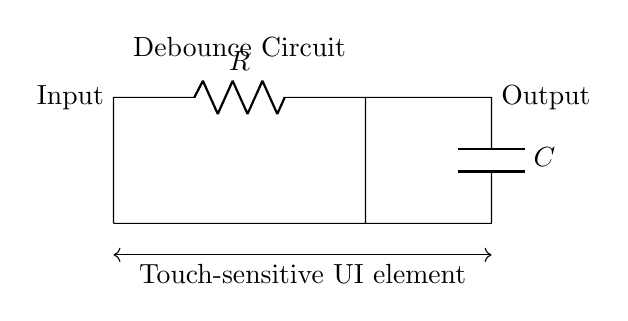What components are present in this circuit? The circuit includes a resistor labeled R and a capacitor labeled C. These are the primary components responsible for the functionality of the debounce circuit.
Answer: Resistor and Capacitor What does the input node represent? The input node is connected to the touch-sensitive UI element, which is the source of the signal that the circuit will debounce. It converts mechanical touch into an electrical signal.
Answer: Touch-sensitive UI element What is the purpose of the capacitor in this circuit? The capacitor stores electrical charge and works with the resistor to filter out rapid fluctuations in the input signal, smoothing the transition and effectively debouncing the signal.
Answer: Filter noise What kind of circuit is this? This is a resistor-capacitor (RC) debounce circuit. It uses the time constant created by the resistor and capacitor to delay changes in the output, thus improving responsiveness.
Answer: Debounce circuit How does this debounce circuit improve responsiveness? The resistor-capacitor pair creates a low-pass filter that reduces the effects of signal bounce from the touch input, allowing for a cleaner, more stable signal. This means that brief disturbances are ignored, leading to fewer erroneous activations.
Answer: Signal stabilization 